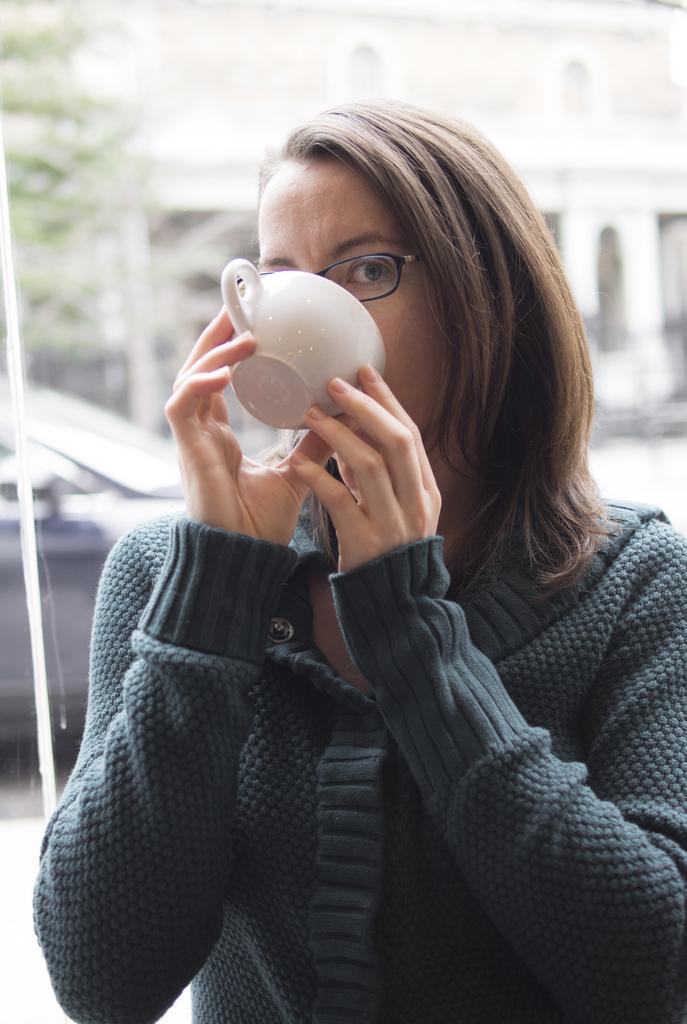How would you summarize this image in a sentence or two? This picture consists of a woman standing and drinking a tea from the cup. In the background, there is a building of white in color. In the left, tree is visible which is half. In the middle, a car is visible which is also half. This image is taken during day time on the road. 